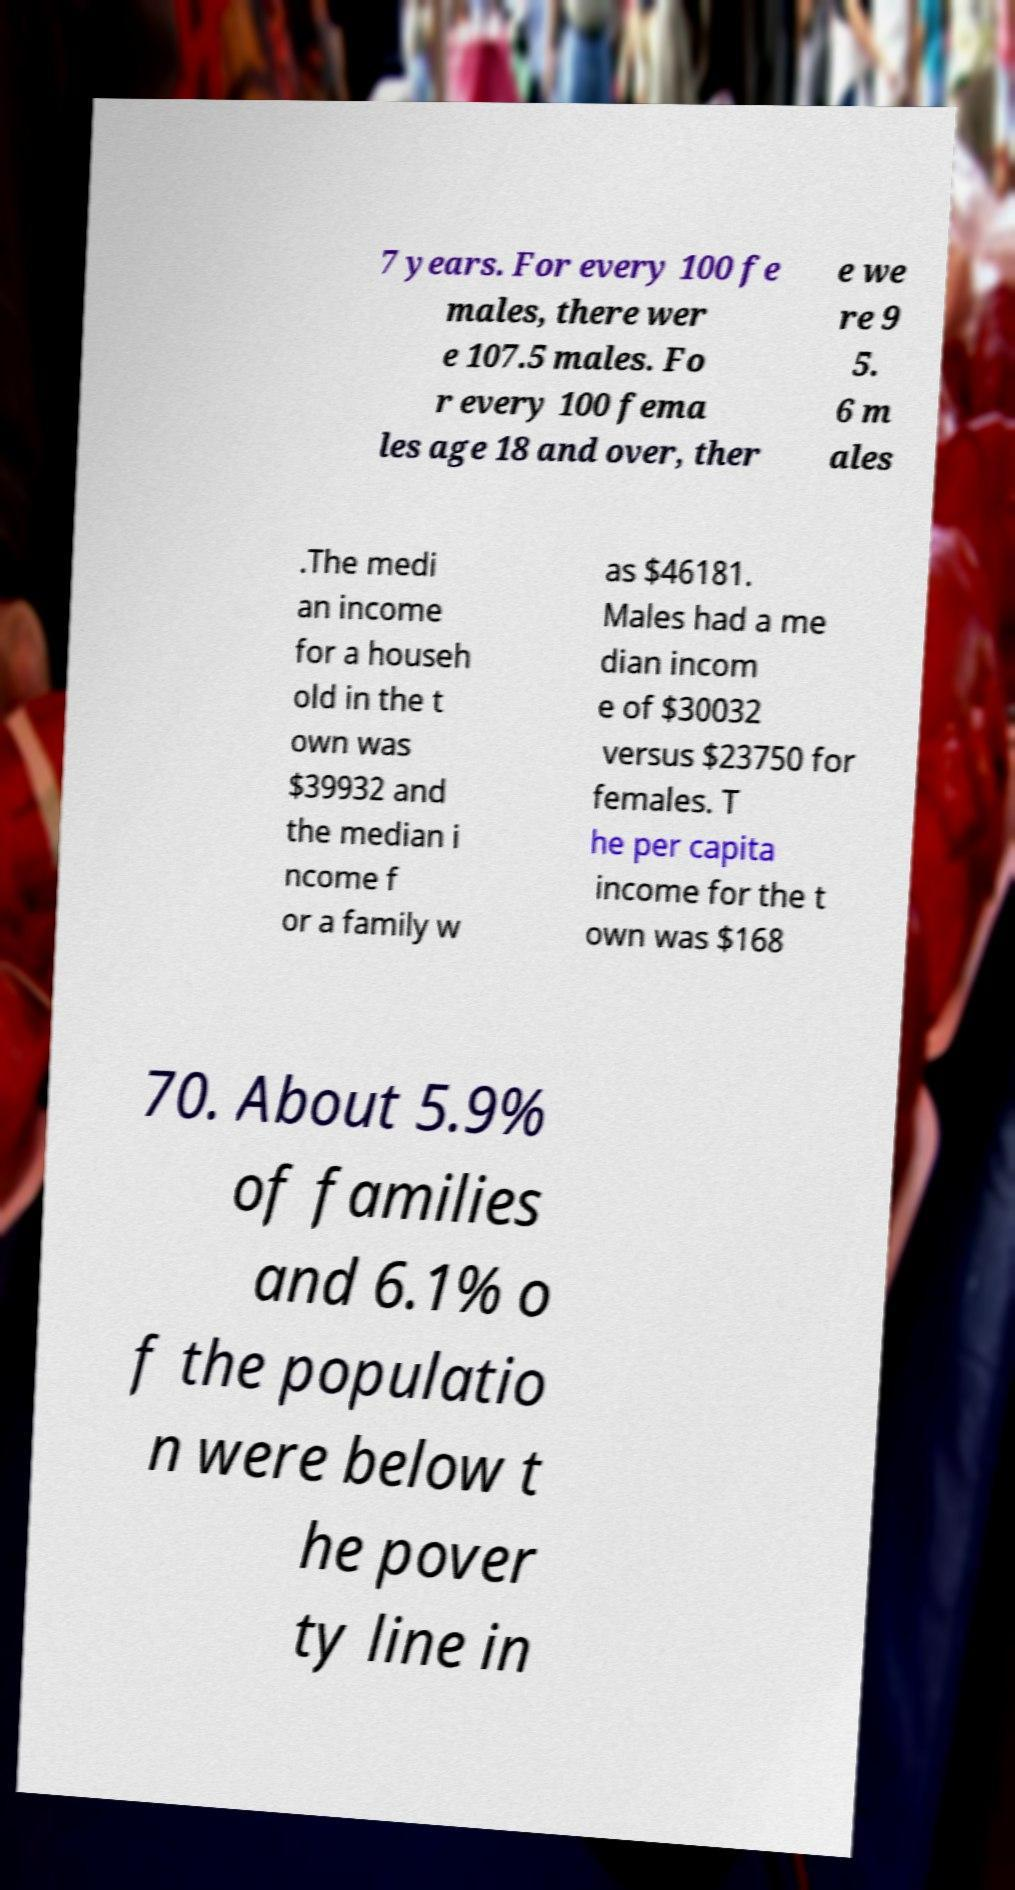Could you extract and type out the text from this image? 7 years. For every 100 fe males, there wer e 107.5 males. Fo r every 100 fema les age 18 and over, ther e we re 9 5. 6 m ales .The medi an income for a househ old in the t own was $39932 and the median i ncome f or a family w as $46181. Males had a me dian incom e of $30032 versus $23750 for females. T he per capita income for the t own was $168 70. About 5.9% of families and 6.1% o f the populatio n were below t he pover ty line in 